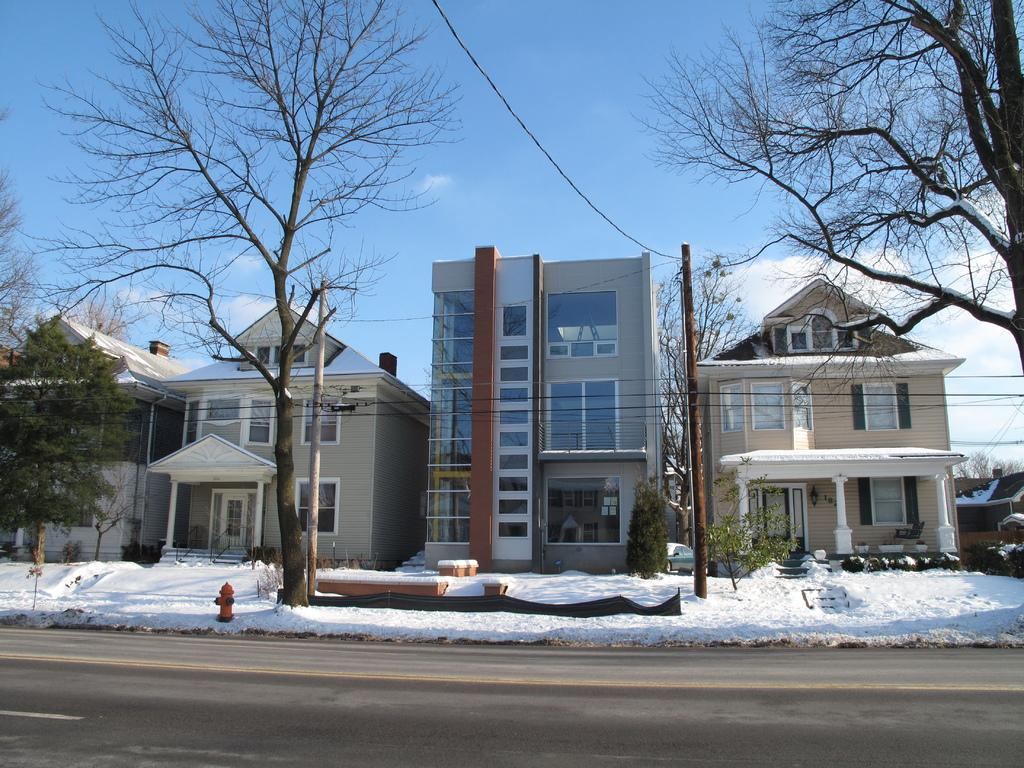What type of weather is depicted in the image? The image contains snow, indicating a cold and wintry weather condition. What object can be seen in the image that is typically used for firefighting? There is a hydrant in the image. What type of natural elements are present in the image? Trees and plants are visible in the image. What man-made structures can be seen in the image? Poles, buildings, and a road are visible in the image. What is visible in the background of the image? The sky is visible in the background of the image, with clouds present. What type of cheese is being used to cover the cloth in the image? There is no cheese or cloth present in the image; it features snow, a hydrant, trees, plants, poles, buildings, a road, and a sky with clouds. Where is the bath located in the image? There is no bath present in the image. 